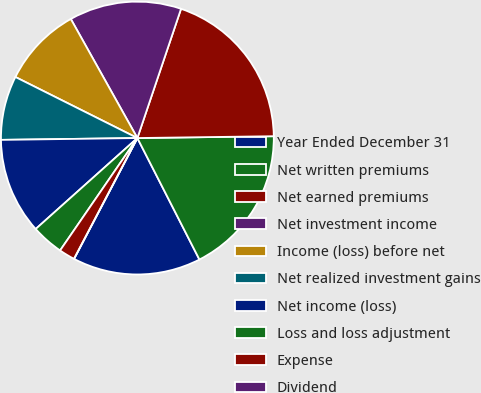Convert chart to OTSL. <chart><loc_0><loc_0><loc_500><loc_500><pie_chart><fcel>Year Ended December 31<fcel>Net written premiums<fcel>Net earned premiums<fcel>Net investment income<fcel>Income (loss) before net<fcel>Net realized investment gains<fcel>Net income (loss)<fcel>Loss and loss adjustment<fcel>Expense<fcel>Dividend<nl><fcel>15.2%<fcel>17.7%<fcel>19.6%<fcel>13.3%<fcel>9.5%<fcel>7.6%<fcel>11.4%<fcel>3.8%<fcel>1.9%<fcel>0.0%<nl></chart> 